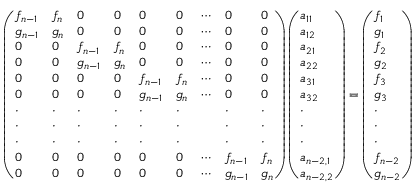Convert formula to latex. <formula><loc_0><loc_0><loc_500><loc_500>\left ( \begin{array} { l l l l l l l l l } { f _ { n - 1 } } & { f _ { n } } & { 0 } & { 0 } & { 0 } & { 0 } & { \cdots } & { 0 } & { 0 } \\ { g _ { n - 1 } } & { g _ { n } } & { 0 } & { 0 } & { 0 } & { 0 } & { \cdots } & { 0 } & { 0 } \\ { 0 } & { 0 } & { f _ { n - 1 } } & { f _ { n } } & { 0 } & { 0 } & { \cdots } & { 0 } & { 0 } \\ { 0 } & { 0 } & { g _ { n - 1 } } & { g _ { n } } & { 0 } & { 0 } & { \cdots } & { 0 } & { 0 } \\ { 0 } & { 0 } & { 0 } & { 0 } & { f _ { n - 1 } } & { f _ { n } } & { \cdots } & { 0 } & { 0 } \\ { 0 } & { 0 } & { 0 } & { 0 } & { g _ { n - 1 } } & { g _ { n } } & { \cdots } & { 0 } & { 0 } \\ { \cdot } & { \cdot } & { \cdot } & { \cdot } & { \cdot } & { \cdot } & & { \cdot } & { \cdot } \\ { \cdot } & { \cdot } & { \cdot } & { \cdot } & { \cdot } & { \cdot } & & { \cdot } & { \cdot } \\ { \cdot } & { \cdot } & { \cdot } & { \cdot } & { \cdot } & { \cdot } & & { \cdot } & { \cdot } \\ { 0 } & { 0 } & { 0 } & { 0 } & { 0 } & { 0 } & { \cdots } & { f _ { n - 1 } } & { f _ { n } } \\ { 0 } & { 0 } & { 0 } & { 0 } & { 0 } & { 0 } & { \cdots } & { g _ { n - 1 } } & { g _ { n } } \end{array} \right ) \left ( \begin{array} { l } { a _ { 1 1 } } \\ { a _ { 1 2 } } \\ { a _ { 2 1 } } \\ { a _ { 2 2 } } \\ { a _ { 3 1 } } \\ { a _ { 3 2 } } \\ { \cdot } \\ { \cdot } \\ { \cdot } \\ { a _ { n - 2 , 1 } } \\ { a _ { n - 2 , 2 } } \end{array} \right ) = \left ( \begin{array} { l } { f _ { 1 } } \\ { g _ { 1 } } \\ { f _ { 2 } } \\ { g _ { 2 } } \\ { f _ { 3 } } \\ { g _ { 3 } } \\ { \cdot } \\ { \cdot } \\ { \cdot } \\ { f _ { n - 2 } } \\ { g _ { n - 2 } } \end{array} \right )</formula> 